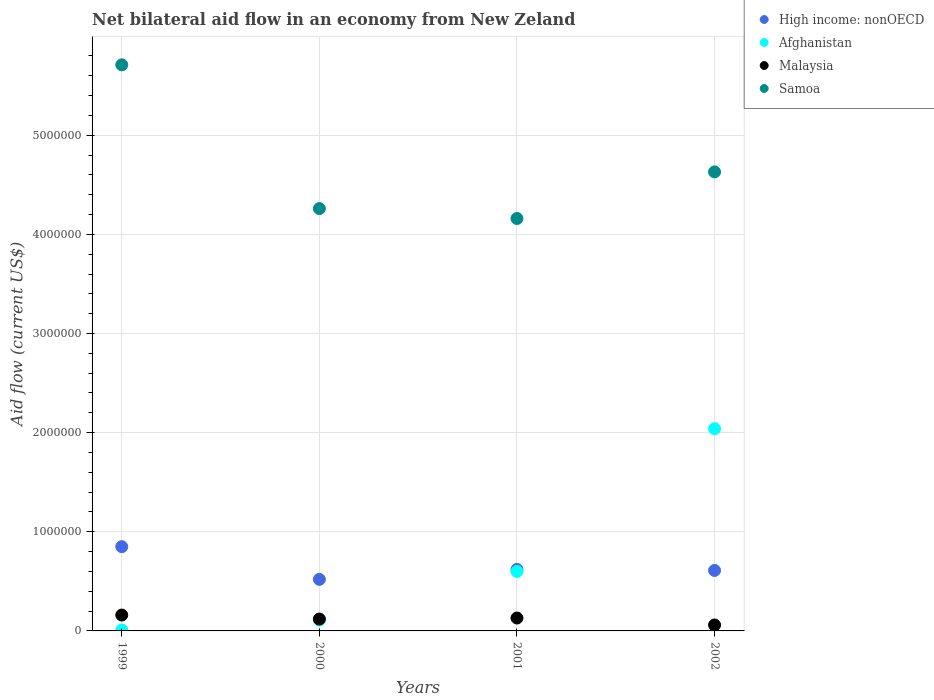Is the number of dotlines equal to the number of legend labels?
Keep it short and to the point. Yes. What is the net bilateral aid flow in Samoa in 2001?
Provide a short and direct response. 4.16e+06. Across all years, what is the maximum net bilateral aid flow in High income: nonOECD?
Give a very brief answer. 8.50e+05. Across all years, what is the minimum net bilateral aid flow in Samoa?
Provide a short and direct response. 4.16e+06. What is the total net bilateral aid flow in High income: nonOECD in the graph?
Give a very brief answer. 2.60e+06. What is the difference between the net bilateral aid flow in Malaysia in 2001 and the net bilateral aid flow in Afghanistan in 2000?
Your answer should be very brief. 2.00e+04. What is the average net bilateral aid flow in Malaysia per year?
Offer a very short reply. 1.18e+05. In the year 1999, what is the difference between the net bilateral aid flow in Samoa and net bilateral aid flow in Afghanistan?
Offer a very short reply. 5.70e+06. What is the ratio of the net bilateral aid flow in Afghanistan in 1999 to that in 2001?
Provide a short and direct response. 0.02. Is the difference between the net bilateral aid flow in Samoa in 1999 and 2000 greater than the difference between the net bilateral aid flow in Afghanistan in 1999 and 2000?
Your answer should be compact. Yes. What is the difference between the highest and the second highest net bilateral aid flow in Samoa?
Offer a terse response. 1.08e+06. Is the sum of the net bilateral aid flow in Afghanistan in 1999 and 2001 greater than the maximum net bilateral aid flow in Samoa across all years?
Keep it short and to the point. No. Is it the case that in every year, the sum of the net bilateral aid flow in Afghanistan and net bilateral aid flow in High income: nonOECD  is greater than the sum of net bilateral aid flow in Samoa and net bilateral aid flow in Malaysia?
Your answer should be compact. Yes. Does the net bilateral aid flow in High income: nonOECD monotonically increase over the years?
Offer a very short reply. No. Is the net bilateral aid flow in Samoa strictly greater than the net bilateral aid flow in Afghanistan over the years?
Offer a terse response. Yes. How many dotlines are there?
Offer a very short reply. 4. Does the graph contain any zero values?
Provide a succinct answer. No. Does the graph contain grids?
Give a very brief answer. Yes. What is the title of the graph?
Your answer should be compact. Net bilateral aid flow in an economy from New Zeland. What is the label or title of the X-axis?
Make the answer very short. Years. What is the Aid flow (current US$) in High income: nonOECD in 1999?
Provide a succinct answer. 8.50e+05. What is the Aid flow (current US$) in Afghanistan in 1999?
Offer a very short reply. 10000. What is the Aid flow (current US$) in Samoa in 1999?
Provide a succinct answer. 5.71e+06. What is the Aid flow (current US$) in High income: nonOECD in 2000?
Your answer should be very brief. 5.20e+05. What is the Aid flow (current US$) in Afghanistan in 2000?
Make the answer very short. 1.10e+05. What is the Aid flow (current US$) of Samoa in 2000?
Keep it short and to the point. 4.26e+06. What is the Aid flow (current US$) of High income: nonOECD in 2001?
Offer a terse response. 6.20e+05. What is the Aid flow (current US$) of Malaysia in 2001?
Give a very brief answer. 1.30e+05. What is the Aid flow (current US$) in Samoa in 2001?
Offer a terse response. 4.16e+06. What is the Aid flow (current US$) in High income: nonOECD in 2002?
Keep it short and to the point. 6.10e+05. What is the Aid flow (current US$) in Afghanistan in 2002?
Offer a terse response. 2.04e+06. What is the Aid flow (current US$) of Samoa in 2002?
Your response must be concise. 4.63e+06. Across all years, what is the maximum Aid flow (current US$) in High income: nonOECD?
Ensure brevity in your answer.  8.50e+05. Across all years, what is the maximum Aid flow (current US$) of Afghanistan?
Make the answer very short. 2.04e+06. Across all years, what is the maximum Aid flow (current US$) of Malaysia?
Keep it short and to the point. 1.60e+05. Across all years, what is the maximum Aid flow (current US$) in Samoa?
Your answer should be compact. 5.71e+06. Across all years, what is the minimum Aid flow (current US$) of High income: nonOECD?
Your answer should be compact. 5.20e+05. Across all years, what is the minimum Aid flow (current US$) of Malaysia?
Provide a short and direct response. 6.00e+04. Across all years, what is the minimum Aid flow (current US$) of Samoa?
Give a very brief answer. 4.16e+06. What is the total Aid flow (current US$) in High income: nonOECD in the graph?
Offer a terse response. 2.60e+06. What is the total Aid flow (current US$) of Afghanistan in the graph?
Make the answer very short. 2.76e+06. What is the total Aid flow (current US$) of Samoa in the graph?
Ensure brevity in your answer.  1.88e+07. What is the difference between the Aid flow (current US$) of High income: nonOECD in 1999 and that in 2000?
Your answer should be very brief. 3.30e+05. What is the difference between the Aid flow (current US$) in Malaysia in 1999 and that in 2000?
Your answer should be compact. 4.00e+04. What is the difference between the Aid flow (current US$) in Samoa in 1999 and that in 2000?
Provide a short and direct response. 1.45e+06. What is the difference between the Aid flow (current US$) in High income: nonOECD in 1999 and that in 2001?
Provide a short and direct response. 2.30e+05. What is the difference between the Aid flow (current US$) of Afghanistan in 1999 and that in 2001?
Your answer should be compact. -5.90e+05. What is the difference between the Aid flow (current US$) in Malaysia in 1999 and that in 2001?
Make the answer very short. 3.00e+04. What is the difference between the Aid flow (current US$) in Samoa in 1999 and that in 2001?
Offer a very short reply. 1.55e+06. What is the difference between the Aid flow (current US$) in High income: nonOECD in 1999 and that in 2002?
Give a very brief answer. 2.40e+05. What is the difference between the Aid flow (current US$) in Afghanistan in 1999 and that in 2002?
Keep it short and to the point. -2.03e+06. What is the difference between the Aid flow (current US$) in Malaysia in 1999 and that in 2002?
Provide a short and direct response. 1.00e+05. What is the difference between the Aid flow (current US$) of Samoa in 1999 and that in 2002?
Your answer should be compact. 1.08e+06. What is the difference between the Aid flow (current US$) of Afghanistan in 2000 and that in 2001?
Your response must be concise. -4.90e+05. What is the difference between the Aid flow (current US$) in Samoa in 2000 and that in 2001?
Your answer should be compact. 1.00e+05. What is the difference between the Aid flow (current US$) in High income: nonOECD in 2000 and that in 2002?
Your response must be concise. -9.00e+04. What is the difference between the Aid flow (current US$) in Afghanistan in 2000 and that in 2002?
Give a very brief answer. -1.93e+06. What is the difference between the Aid flow (current US$) of Samoa in 2000 and that in 2002?
Your response must be concise. -3.70e+05. What is the difference between the Aid flow (current US$) in High income: nonOECD in 2001 and that in 2002?
Give a very brief answer. 10000. What is the difference between the Aid flow (current US$) of Afghanistan in 2001 and that in 2002?
Make the answer very short. -1.44e+06. What is the difference between the Aid flow (current US$) in Malaysia in 2001 and that in 2002?
Give a very brief answer. 7.00e+04. What is the difference between the Aid flow (current US$) of Samoa in 2001 and that in 2002?
Offer a very short reply. -4.70e+05. What is the difference between the Aid flow (current US$) of High income: nonOECD in 1999 and the Aid flow (current US$) of Afghanistan in 2000?
Give a very brief answer. 7.40e+05. What is the difference between the Aid flow (current US$) of High income: nonOECD in 1999 and the Aid flow (current US$) of Malaysia in 2000?
Make the answer very short. 7.30e+05. What is the difference between the Aid flow (current US$) of High income: nonOECD in 1999 and the Aid flow (current US$) of Samoa in 2000?
Offer a very short reply. -3.41e+06. What is the difference between the Aid flow (current US$) in Afghanistan in 1999 and the Aid flow (current US$) in Malaysia in 2000?
Provide a succinct answer. -1.10e+05. What is the difference between the Aid flow (current US$) of Afghanistan in 1999 and the Aid flow (current US$) of Samoa in 2000?
Your answer should be compact. -4.25e+06. What is the difference between the Aid flow (current US$) in Malaysia in 1999 and the Aid flow (current US$) in Samoa in 2000?
Your answer should be very brief. -4.10e+06. What is the difference between the Aid flow (current US$) in High income: nonOECD in 1999 and the Aid flow (current US$) in Malaysia in 2001?
Offer a terse response. 7.20e+05. What is the difference between the Aid flow (current US$) in High income: nonOECD in 1999 and the Aid flow (current US$) in Samoa in 2001?
Provide a succinct answer. -3.31e+06. What is the difference between the Aid flow (current US$) in Afghanistan in 1999 and the Aid flow (current US$) in Malaysia in 2001?
Ensure brevity in your answer.  -1.20e+05. What is the difference between the Aid flow (current US$) of Afghanistan in 1999 and the Aid flow (current US$) of Samoa in 2001?
Give a very brief answer. -4.15e+06. What is the difference between the Aid flow (current US$) in High income: nonOECD in 1999 and the Aid flow (current US$) in Afghanistan in 2002?
Provide a short and direct response. -1.19e+06. What is the difference between the Aid flow (current US$) in High income: nonOECD in 1999 and the Aid flow (current US$) in Malaysia in 2002?
Ensure brevity in your answer.  7.90e+05. What is the difference between the Aid flow (current US$) in High income: nonOECD in 1999 and the Aid flow (current US$) in Samoa in 2002?
Provide a short and direct response. -3.78e+06. What is the difference between the Aid flow (current US$) of Afghanistan in 1999 and the Aid flow (current US$) of Malaysia in 2002?
Offer a terse response. -5.00e+04. What is the difference between the Aid flow (current US$) in Afghanistan in 1999 and the Aid flow (current US$) in Samoa in 2002?
Provide a succinct answer. -4.62e+06. What is the difference between the Aid flow (current US$) of Malaysia in 1999 and the Aid flow (current US$) of Samoa in 2002?
Provide a short and direct response. -4.47e+06. What is the difference between the Aid flow (current US$) in High income: nonOECD in 2000 and the Aid flow (current US$) in Afghanistan in 2001?
Ensure brevity in your answer.  -8.00e+04. What is the difference between the Aid flow (current US$) in High income: nonOECD in 2000 and the Aid flow (current US$) in Samoa in 2001?
Make the answer very short. -3.64e+06. What is the difference between the Aid flow (current US$) of Afghanistan in 2000 and the Aid flow (current US$) of Malaysia in 2001?
Provide a short and direct response. -2.00e+04. What is the difference between the Aid flow (current US$) in Afghanistan in 2000 and the Aid flow (current US$) in Samoa in 2001?
Your response must be concise. -4.05e+06. What is the difference between the Aid flow (current US$) in Malaysia in 2000 and the Aid flow (current US$) in Samoa in 2001?
Ensure brevity in your answer.  -4.04e+06. What is the difference between the Aid flow (current US$) in High income: nonOECD in 2000 and the Aid flow (current US$) in Afghanistan in 2002?
Provide a succinct answer. -1.52e+06. What is the difference between the Aid flow (current US$) of High income: nonOECD in 2000 and the Aid flow (current US$) of Samoa in 2002?
Your answer should be compact. -4.11e+06. What is the difference between the Aid flow (current US$) of Afghanistan in 2000 and the Aid flow (current US$) of Samoa in 2002?
Offer a very short reply. -4.52e+06. What is the difference between the Aid flow (current US$) in Malaysia in 2000 and the Aid flow (current US$) in Samoa in 2002?
Ensure brevity in your answer.  -4.51e+06. What is the difference between the Aid flow (current US$) of High income: nonOECD in 2001 and the Aid flow (current US$) of Afghanistan in 2002?
Your answer should be compact. -1.42e+06. What is the difference between the Aid flow (current US$) in High income: nonOECD in 2001 and the Aid flow (current US$) in Malaysia in 2002?
Give a very brief answer. 5.60e+05. What is the difference between the Aid flow (current US$) in High income: nonOECD in 2001 and the Aid flow (current US$) in Samoa in 2002?
Make the answer very short. -4.01e+06. What is the difference between the Aid flow (current US$) of Afghanistan in 2001 and the Aid flow (current US$) of Malaysia in 2002?
Ensure brevity in your answer.  5.40e+05. What is the difference between the Aid flow (current US$) of Afghanistan in 2001 and the Aid flow (current US$) of Samoa in 2002?
Your response must be concise. -4.03e+06. What is the difference between the Aid flow (current US$) in Malaysia in 2001 and the Aid flow (current US$) in Samoa in 2002?
Your response must be concise. -4.50e+06. What is the average Aid flow (current US$) of High income: nonOECD per year?
Provide a succinct answer. 6.50e+05. What is the average Aid flow (current US$) in Afghanistan per year?
Your answer should be very brief. 6.90e+05. What is the average Aid flow (current US$) of Malaysia per year?
Your answer should be very brief. 1.18e+05. What is the average Aid flow (current US$) of Samoa per year?
Offer a very short reply. 4.69e+06. In the year 1999, what is the difference between the Aid flow (current US$) in High income: nonOECD and Aid flow (current US$) in Afghanistan?
Make the answer very short. 8.40e+05. In the year 1999, what is the difference between the Aid flow (current US$) of High income: nonOECD and Aid flow (current US$) of Malaysia?
Your response must be concise. 6.90e+05. In the year 1999, what is the difference between the Aid flow (current US$) of High income: nonOECD and Aid flow (current US$) of Samoa?
Provide a short and direct response. -4.86e+06. In the year 1999, what is the difference between the Aid flow (current US$) of Afghanistan and Aid flow (current US$) of Malaysia?
Offer a terse response. -1.50e+05. In the year 1999, what is the difference between the Aid flow (current US$) in Afghanistan and Aid flow (current US$) in Samoa?
Offer a very short reply. -5.70e+06. In the year 1999, what is the difference between the Aid flow (current US$) of Malaysia and Aid flow (current US$) of Samoa?
Keep it short and to the point. -5.55e+06. In the year 2000, what is the difference between the Aid flow (current US$) of High income: nonOECD and Aid flow (current US$) of Afghanistan?
Your answer should be compact. 4.10e+05. In the year 2000, what is the difference between the Aid flow (current US$) of High income: nonOECD and Aid flow (current US$) of Samoa?
Your answer should be very brief. -3.74e+06. In the year 2000, what is the difference between the Aid flow (current US$) of Afghanistan and Aid flow (current US$) of Malaysia?
Provide a short and direct response. -10000. In the year 2000, what is the difference between the Aid flow (current US$) in Afghanistan and Aid flow (current US$) in Samoa?
Keep it short and to the point. -4.15e+06. In the year 2000, what is the difference between the Aid flow (current US$) of Malaysia and Aid flow (current US$) of Samoa?
Make the answer very short. -4.14e+06. In the year 2001, what is the difference between the Aid flow (current US$) of High income: nonOECD and Aid flow (current US$) of Afghanistan?
Provide a succinct answer. 2.00e+04. In the year 2001, what is the difference between the Aid flow (current US$) of High income: nonOECD and Aid flow (current US$) of Malaysia?
Ensure brevity in your answer.  4.90e+05. In the year 2001, what is the difference between the Aid flow (current US$) of High income: nonOECD and Aid flow (current US$) of Samoa?
Make the answer very short. -3.54e+06. In the year 2001, what is the difference between the Aid flow (current US$) of Afghanistan and Aid flow (current US$) of Malaysia?
Make the answer very short. 4.70e+05. In the year 2001, what is the difference between the Aid flow (current US$) in Afghanistan and Aid flow (current US$) in Samoa?
Give a very brief answer. -3.56e+06. In the year 2001, what is the difference between the Aid flow (current US$) of Malaysia and Aid flow (current US$) of Samoa?
Your response must be concise. -4.03e+06. In the year 2002, what is the difference between the Aid flow (current US$) of High income: nonOECD and Aid flow (current US$) of Afghanistan?
Ensure brevity in your answer.  -1.43e+06. In the year 2002, what is the difference between the Aid flow (current US$) in High income: nonOECD and Aid flow (current US$) in Samoa?
Your answer should be very brief. -4.02e+06. In the year 2002, what is the difference between the Aid flow (current US$) in Afghanistan and Aid flow (current US$) in Malaysia?
Your answer should be very brief. 1.98e+06. In the year 2002, what is the difference between the Aid flow (current US$) in Afghanistan and Aid flow (current US$) in Samoa?
Give a very brief answer. -2.59e+06. In the year 2002, what is the difference between the Aid flow (current US$) in Malaysia and Aid flow (current US$) in Samoa?
Your response must be concise. -4.57e+06. What is the ratio of the Aid flow (current US$) in High income: nonOECD in 1999 to that in 2000?
Your response must be concise. 1.63. What is the ratio of the Aid flow (current US$) of Afghanistan in 1999 to that in 2000?
Keep it short and to the point. 0.09. What is the ratio of the Aid flow (current US$) of Samoa in 1999 to that in 2000?
Keep it short and to the point. 1.34. What is the ratio of the Aid flow (current US$) of High income: nonOECD in 1999 to that in 2001?
Ensure brevity in your answer.  1.37. What is the ratio of the Aid flow (current US$) of Afghanistan in 1999 to that in 2001?
Offer a terse response. 0.02. What is the ratio of the Aid flow (current US$) in Malaysia in 1999 to that in 2001?
Offer a very short reply. 1.23. What is the ratio of the Aid flow (current US$) of Samoa in 1999 to that in 2001?
Ensure brevity in your answer.  1.37. What is the ratio of the Aid flow (current US$) in High income: nonOECD in 1999 to that in 2002?
Offer a terse response. 1.39. What is the ratio of the Aid flow (current US$) in Afghanistan in 1999 to that in 2002?
Your answer should be very brief. 0. What is the ratio of the Aid flow (current US$) of Malaysia in 1999 to that in 2002?
Your answer should be very brief. 2.67. What is the ratio of the Aid flow (current US$) of Samoa in 1999 to that in 2002?
Your answer should be compact. 1.23. What is the ratio of the Aid flow (current US$) in High income: nonOECD in 2000 to that in 2001?
Your answer should be compact. 0.84. What is the ratio of the Aid flow (current US$) of Afghanistan in 2000 to that in 2001?
Offer a terse response. 0.18. What is the ratio of the Aid flow (current US$) of Malaysia in 2000 to that in 2001?
Your response must be concise. 0.92. What is the ratio of the Aid flow (current US$) in High income: nonOECD in 2000 to that in 2002?
Ensure brevity in your answer.  0.85. What is the ratio of the Aid flow (current US$) in Afghanistan in 2000 to that in 2002?
Your answer should be very brief. 0.05. What is the ratio of the Aid flow (current US$) in Malaysia in 2000 to that in 2002?
Your answer should be very brief. 2. What is the ratio of the Aid flow (current US$) of Samoa in 2000 to that in 2002?
Provide a short and direct response. 0.92. What is the ratio of the Aid flow (current US$) of High income: nonOECD in 2001 to that in 2002?
Provide a succinct answer. 1.02. What is the ratio of the Aid flow (current US$) of Afghanistan in 2001 to that in 2002?
Give a very brief answer. 0.29. What is the ratio of the Aid flow (current US$) of Malaysia in 2001 to that in 2002?
Offer a terse response. 2.17. What is the ratio of the Aid flow (current US$) of Samoa in 2001 to that in 2002?
Offer a very short reply. 0.9. What is the difference between the highest and the second highest Aid flow (current US$) in High income: nonOECD?
Offer a very short reply. 2.30e+05. What is the difference between the highest and the second highest Aid flow (current US$) in Afghanistan?
Offer a very short reply. 1.44e+06. What is the difference between the highest and the second highest Aid flow (current US$) in Malaysia?
Offer a very short reply. 3.00e+04. What is the difference between the highest and the second highest Aid flow (current US$) of Samoa?
Give a very brief answer. 1.08e+06. What is the difference between the highest and the lowest Aid flow (current US$) in Afghanistan?
Provide a short and direct response. 2.03e+06. What is the difference between the highest and the lowest Aid flow (current US$) in Malaysia?
Offer a very short reply. 1.00e+05. What is the difference between the highest and the lowest Aid flow (current US$) of Samoa?
Your answer should be compact. 1.55e+06. 